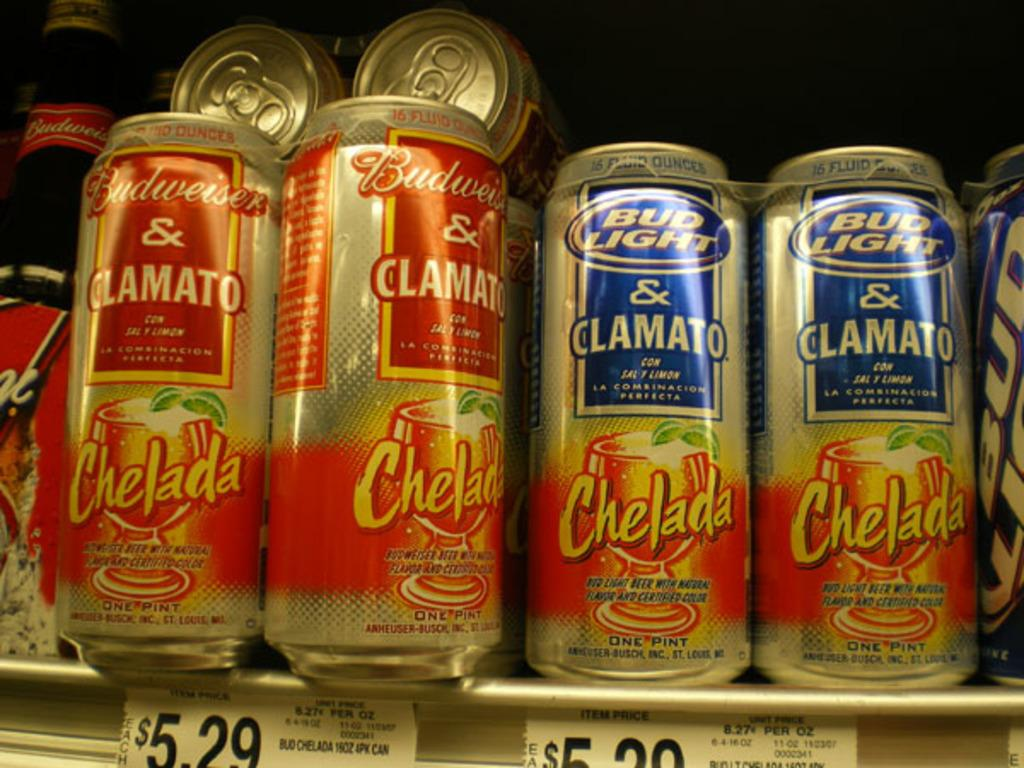<image>
Present a compact description of the photo's key features. A case of cans manufactured by Budweiser that all read Chelada. 